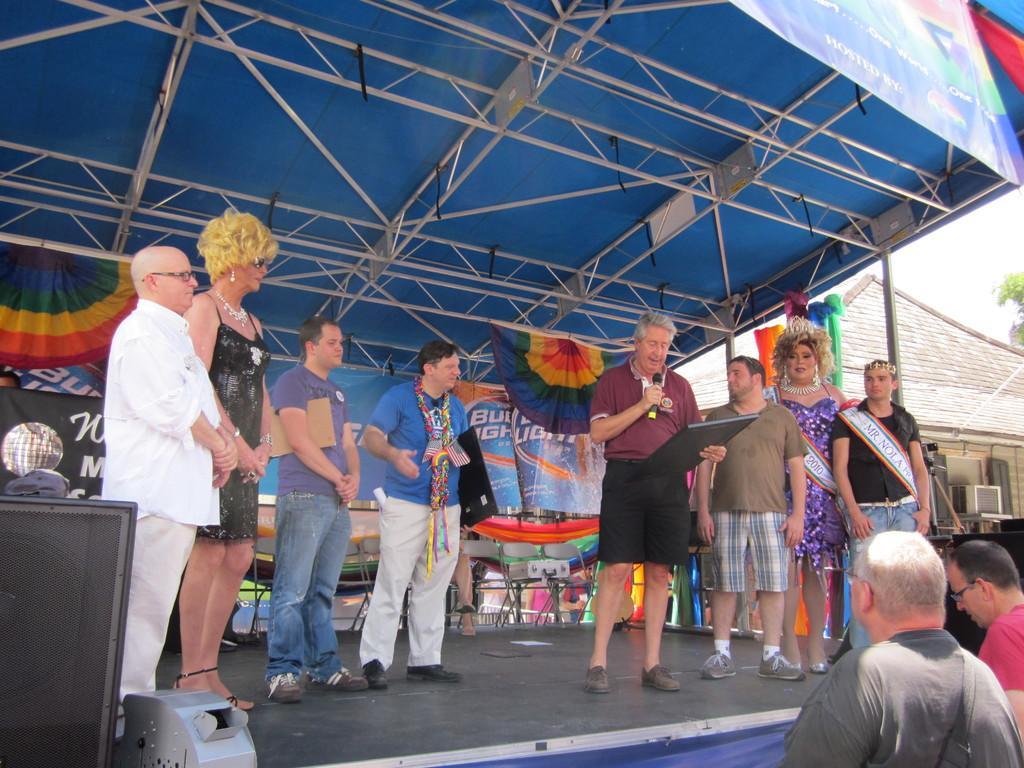Can you describe this image briefly? In this image there is one stage on the stage there are some people who are standing, and one person is holding a mike and board and he is talking something. On the right side there are two persons who are standing and there are some houses and trees, in the background there are some boards, chairs, tables, clothes and some other objects. On the right side there is a speaker and on the top there are some poles and tent, on the top of the image there is one board. 